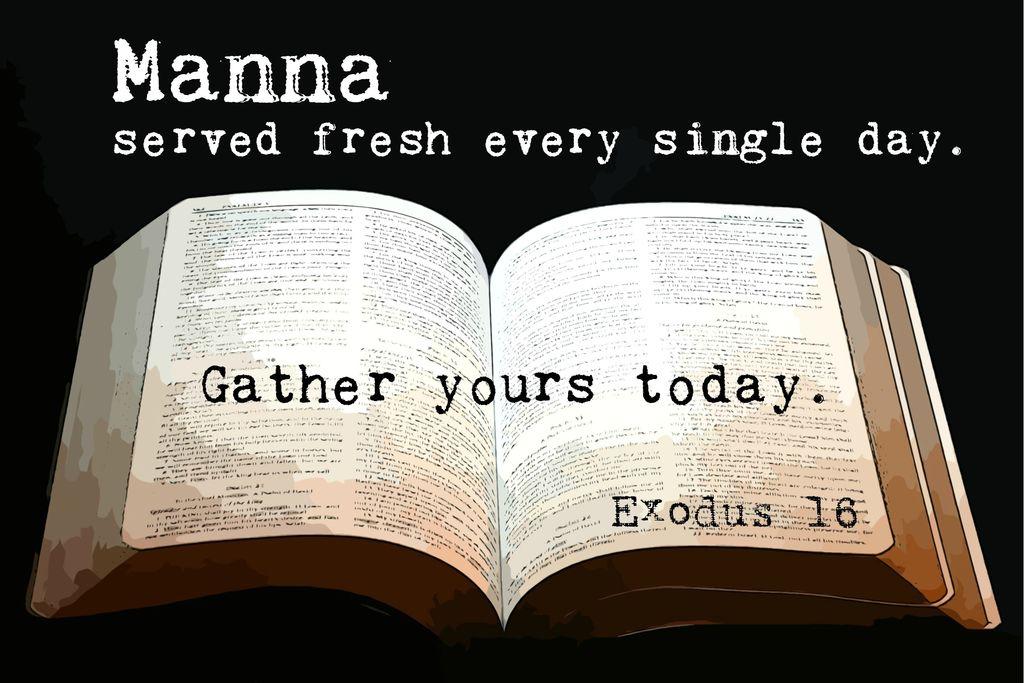What is served fresh?
Provide a short and direct response. Manna. 